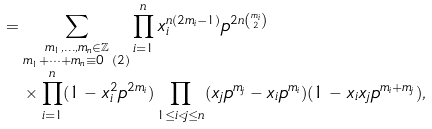<formula> <loc_0><loc_0><loc_500><loc_500>& = \sum _ { \substack { m _ { 1 } , \dots , m _ { n } \in \mathbb { Z } \\ m _ { 1 } + \dots + m _ { n } \equiv 0 \ ( 2 ) } } \prod _ { i = 1 } ^ { n } x _ { i } ^ { n ( 2 m _ { i } - 1 ) } p ^ { 2 n \binom { m _ { i } } 2 } \\ & \quad \times \prod _ { i = 1 } ^ { n } ( 1 - x _ { i } ^ { 2 } p ^ { 2 m _ { i } } ) \prod _ { 1 \leq i < j \leq n } ( x _ { j } p ^ { m _ { j } } - x _ { i } p ^ { m _ { i } } ) ( 1 - x _ { i } x _ { j } p ^ { m _ { i } + m _ { j } } ) ,</formula> 